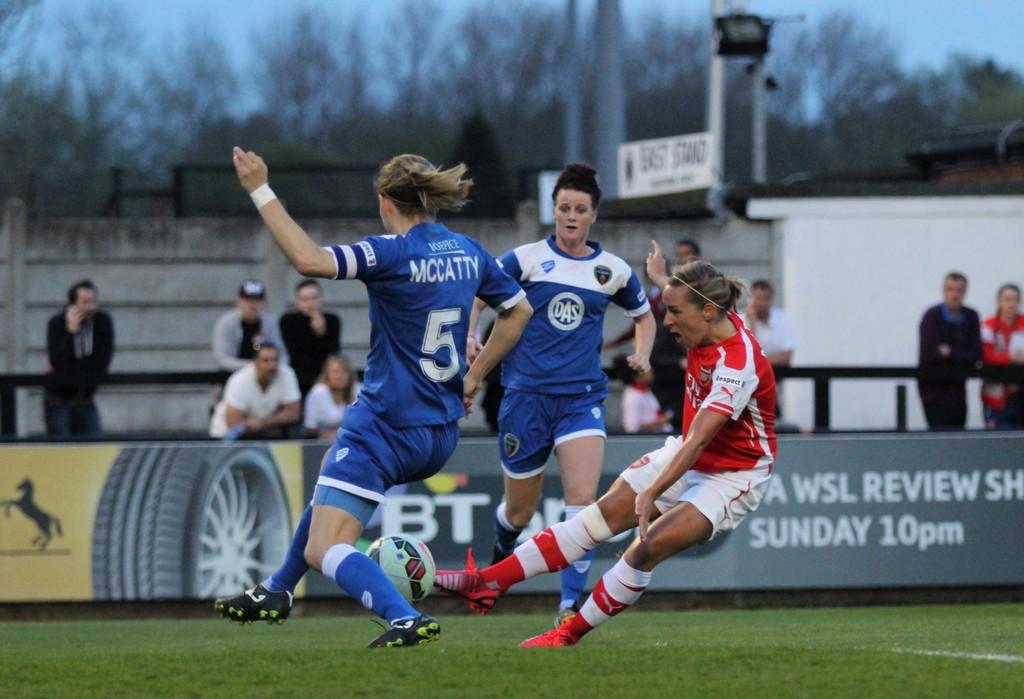What is mccatty's number?
Your response must be concise. 5. What is the brand on the red player's sleeve?
Provide a short and direct response. Puma. 